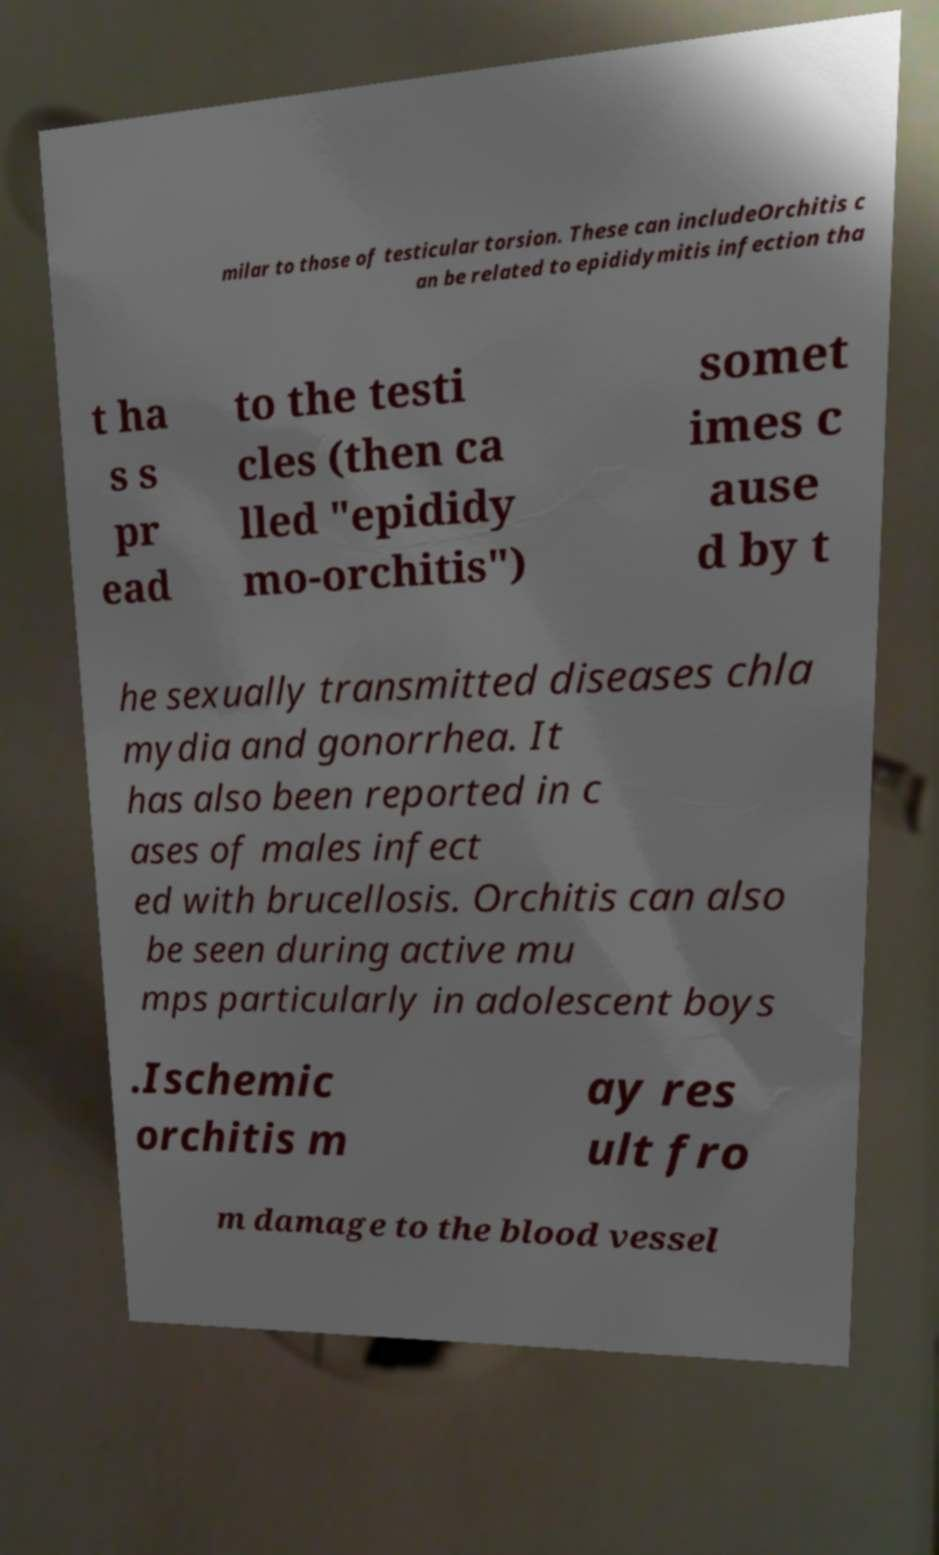What messages or text are displayed in this image? I need them in a readable, typed format. milar to those of testicular torsion. These can includeOrchitis c an be related to epididymitis infection tha t ha s s pr ead to the testi cles (then ca lled "epididy mo-orchitis") somet imes c ause d by t he sexually transmitted diseases chla mydia and gonorrhea. It has also been reported in c ases of males infect ed with brucellosis. Orchitis can also be seen during active mu mps particularly in adolescent boys .Ischemic orchitis m ay res ult fro m damage to the blood vessel 